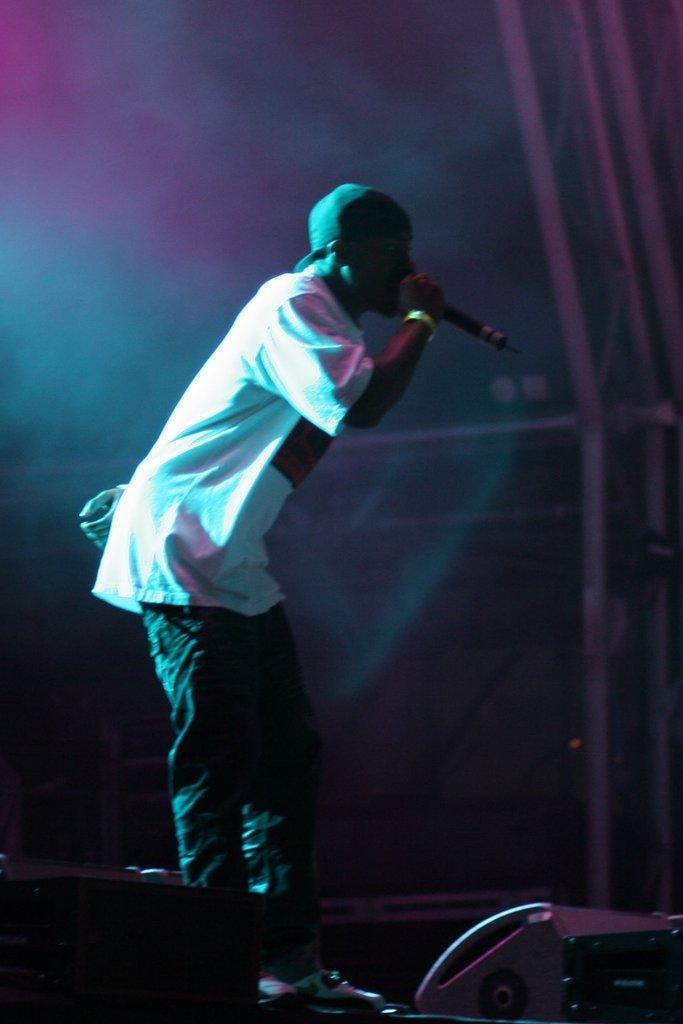How would you summarize this image in a sentence or two? In this image there is a person with a hat is standing and holding a mike, and there is a speaker. 